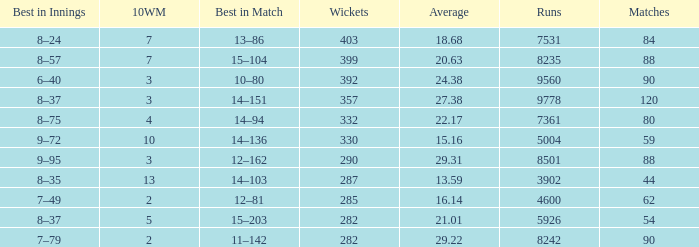What is the cumulative sum of runs related to 10wm values greater than 13? None. 